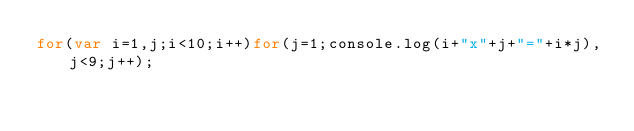<code> <loc_0><loc_0><loc_500><loc_500><_JavaScript_>for(var i=1,j;i<10;i++)for(j=1;console.log(i+"x"+j+"="+i*j),j<9;j++);</code> 